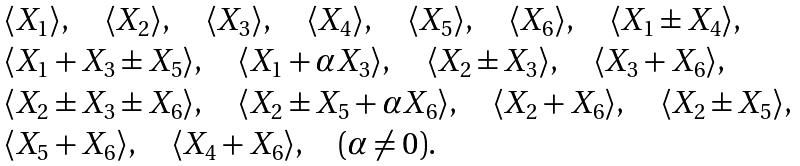Convert formula to latex. <formula><loc_0><loc_0><loc_500><loc_500>\begin{array} { l } \langle X _ { 1 } \rangle , \quad \langle X _ { 2 } \rangle , \quad \langle X _ { 3 } \rangle , \quad \langle X _ { 4 } \rangle , \quad \langle X _ { 5 } \rangle , \quad \langle X _ { 6 } \rangle , \quad \langle X _ { 1 } \pm X _ { 4 } \rangle , \\ \langle X _ { 1 } + X _ { 3 } \pm X _ { 5 } \rangle , \quad \langle X _ { 1 } + \alpha X _ { 3 } \rangle , \quad \langle X _ { 2 } \pm X _ { 3 } \rangle , \quad \langle X _ { 3 } + X _ { 6 } \rangle , \\ \langle X _ { 2 } \pm X _ { 3 } \pm X _ { 6 } \rangle , \quad \langle X _ { 2 } \pm X _ { 5 } + \alpha X _ { 6 } \rangle , \quad \langle X _ { 2 } + X _ { 6 } \rangle , \quad \langle X _ { 2 } \pm X _ { 5 } \rangle , \\ \langle X _ { 5 } + X _ { 6 } \rangle , \quad \langle X _ { 4 } + X _ { 6 } \rangle , \quad ( \alpha \ne 0 ) . \end{array}</formula> 